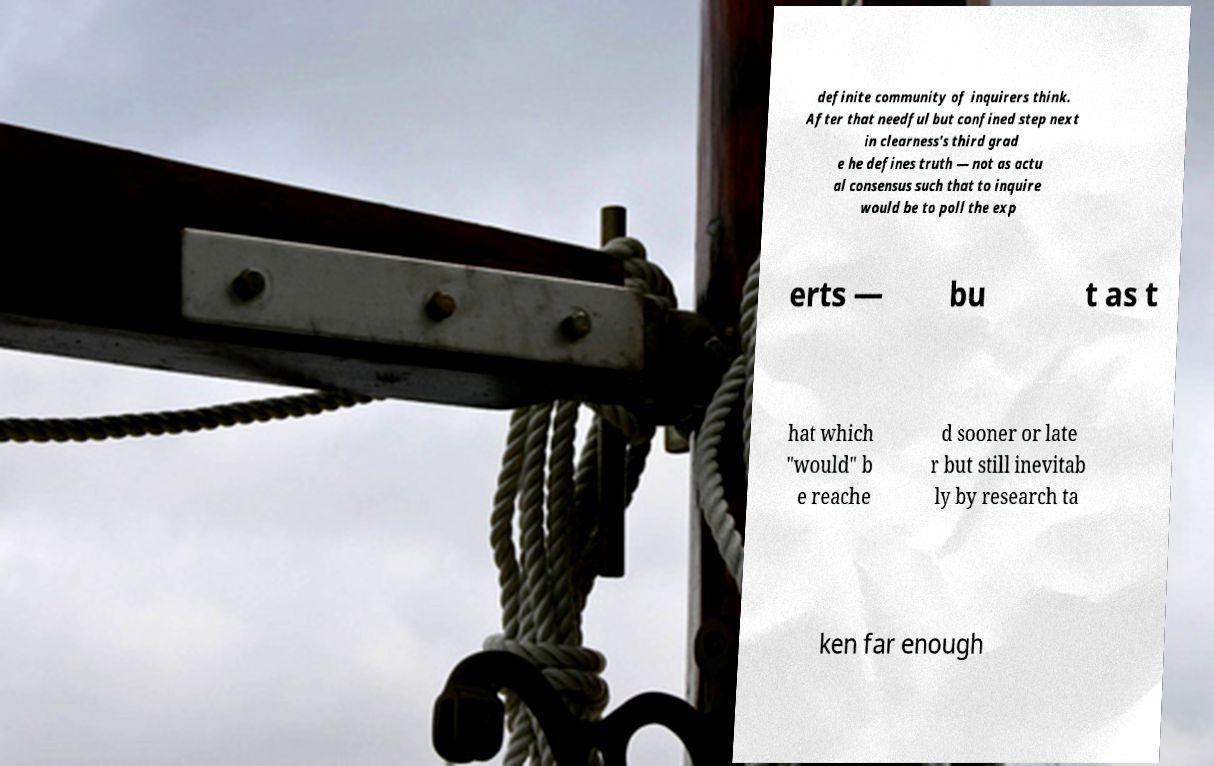I need the written content from this picture converted into text. Can you do that? definite community of inquirers think. After that needful but confined step next in clearness's third grad e he defines truth — not as actu al consensus such that to inquire would be to poll the exp erts — bu t as t hat which "would" b e reache d sooner or late r but still inevitab ly by research ta ken far enough 